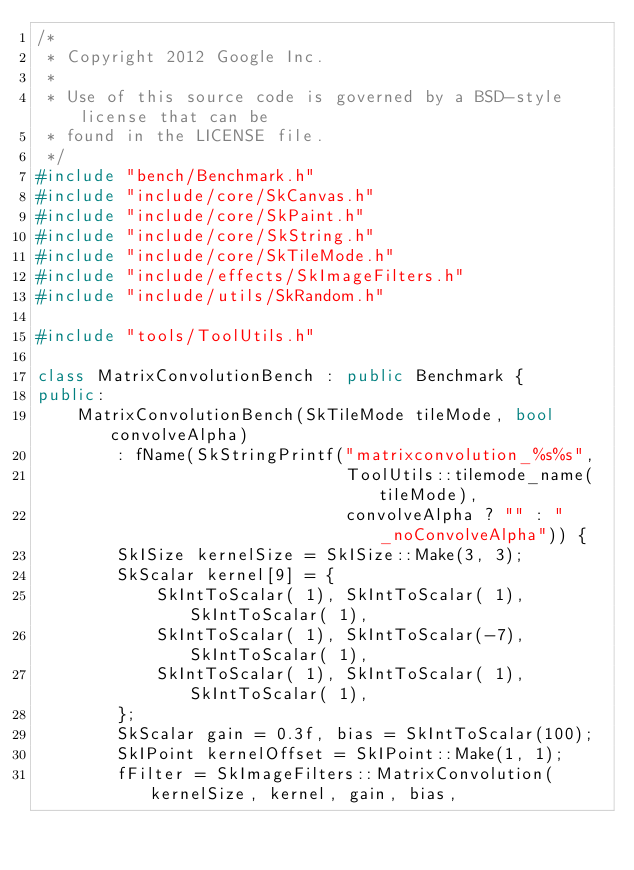<code> <loc_0><loc_0><loc_500><loc_500><_C++_>/*
 * Copyright 2012 Google Inc.
 *
 * Use of this source code is governed by a BSD-style license that can be
 * found in the LICENSE file.
 */
#include "bench/Benchmark.h"
#include "include/core/SkCanvas.h"
#include "include/core/SkPaint.h"
#include "include/core/SkString.h"
#include "include/core/SkTileMode.h"
#include "include/effects/SkImageFilters.h"
#include "include/utils/SkRandom.h"

#include "tools/ToolUtils.h"

class MatrixConvolutionBench : public Benchmark {
public:
    MatrixConvolutionBench(SkTileMode tileMode, bool convolveAlpha)
        : fName(SkStringPrintf("matrixconvolution_%s%s",
                               ToolUtils::tilemode_name(tileMode),
                               convolveAlpha ? "" : "_noConvolveAlpha")) {
        SkISize kernelSize = SkISize::Make(3, 3);
        SkScalar kernel[9] = {
            SkIntToScalar( 1), SkIntToScalar( 1), SkIntToScalar( 1),
            SkIntToScalar( 1), SkIntToScalar(-7), SkIntToScalar( 1),
            SkIntToScalar( 1), SkIntToScalar( 1), SkIntToScalar( 1),
        };
        SkScalar gain = 0.3f, bias = SkIntToScalar(100);
        SkIPoint kernelOffset = SkIPoint::Make(1, 1);
        fFilter = SkImageFilters::MatrixConvolution(kernelSize, kernel, gain, bias,</code> 